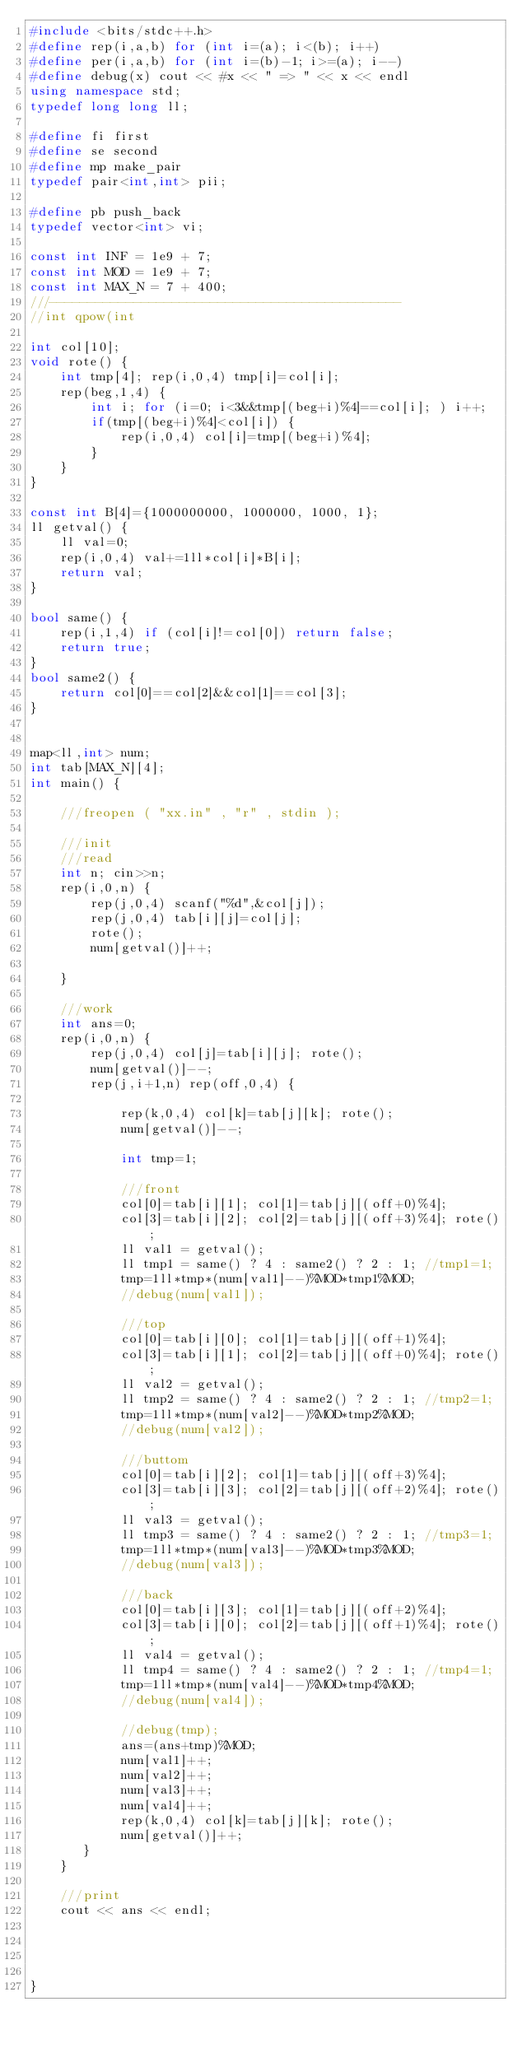Convert code to text. <code><loc_0><loc_0><loc_500><loc_500><_C++_>#include <bits/stdc++.h>
#define rep(i,a,b) for (int i=(a); i<(b); i++)
#define per(i,a,b) for (int i=(b)-1; i>=(a); i--)
#define debug(x) cout << #x << " => " << x << endl
using namespace std;
typedef long long ll;

#define fi first
#define se second
#define mp make_pair
typedef pair<int,int> pii;

#define pb push_back
typedef vector<int> vi;

const int INF = 1e9 + 7;
const int MOD = 1e9 + 7;
const int MAX_N = 7 + 400;
///----------------------------------------------
//int qpow(int

int col[10];
void rote() {
    int tmp[4]; rep(i,0,4) tmp[i]=col[i];
    rep(beg,1,4) {
        int i; for (i=0; i<3&&tmp[(beg+i)%4]==col[i]; ) i++;
        if(tmp[(beg+i)%4]<col[i]) {
            rep(i,0,4) col[i]=tmp[(beg+i)%4];
        }
    }
}

const int B[4]={1000000000, 1000000, 1000, 1};
ll getval() {
    ll val=0;
    rep(i,0,4) val+=1ll*col[i]*B[i];
    return val;
}

bool same() {
    rep(i,1,4) if (col[i]!=col[0]) return false;
    return true;
}
bool same2() {
    return col[0]==col[2]&&col[1]==col[3];
}


map<ll,int> num;
int tab[MAX_N][4];
int main() {

    ///freopen ( "xx.in" , "r" , stdin );

    ///init
    ///read
    int n; cin>>n;
    rep(i,0,n) {
        rep(j,0,4) scanf("%d",&col[j]);
        rep(j,0,4) tab[i][j]=col[j];
        rote();
        num[getval()]++;

    }

    ///work
    int ans=0;
    rep(i,0,n) {
        rep(j,0,4) col[j]=tab[i][j]; rote();
        num[getval()]--;
        rep(j,i+1,n) rep(off,0,4) {

            rep(k,0,4) col[k]=tab[j][k]; rote();
            num[getval()]--;

            int tmp=1;

            ///front
            col[0]=tab[i][1]; col[1]=tab[j][(off+0)%4];
            col[3]=tab[i][2]; col[2]=tab[j][(off+3)%4]; rote();
            ll val1 = getval();
            ll tmp1 = same() ? 4 : same2() ? 2 : 1; //tmp1=1;
            tmp=1ll*tmp*(num[val1]--)%MOD*tmp1%MOD;
            //debug(num[val1]);

            ///top
            col[0]=tab[i][0]; col[1]=tab[j][(off+1)%4];
            col[3]=tab[i][1]; col[2]=tab[j][(off+0)%4]; rote();
            ll val2 = getval();
            ll tmp2 = same() ? 4 : same2() ? 2 : 1; //tmp2=1;
            tmp=1ll*tmp*(num[val2]--)%MOD*tmp2%MOD;
            //debug(num[val2]);

            ///buttom
            col[0]=tab[i][2]; col[1]=tab[j][(off+3)%4];
            col[3]=tab[i][3]; col[2]=tab[j][(off+2)%4]; rote();
            ll val3 = getval();
            ll tmp3 = same() ? 4 : same2() ? 2 : 1; //tmp3=1;
            tmp=1ll*tmp*(num[val3]--)%MOD*tmp3%MOD;
            //debug(num[val3]);

            ///back
            col[0]=tab[i][3]; col[1]=tab[j][(off+2)%4];
            col[3]=tab[i][0]; col[2]=tab[j][(off+1)%4]; rote();
            ll val4 = getval();
            ll tmp4 = same() ? 4 : same2() ? 2 : 1; //tmp4=1;
            tmp=1ll*tmp*(num[val4]--)%MOD*tmp4%MOD;
            //debug(num[val4]);

            //debug(tmp);
            ans=(ans+tmp)%MOD;
            num[val1]++;
            num[val2]++;
            num[val3]++;
            num[val4]++;
            rep(k,0,4) col[k]=tab[j][k]; rote();
            num[getval()]++;
       }
    }

    ///print
    cout << ans << endl;




}











</code> 